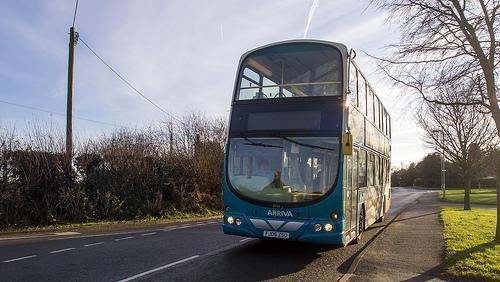How many buses are there?
Give a very brief answer. 1. How many levels do passengers have to sit in on double decker bus?
Give a very brief answer. 2. 